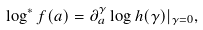<formula> <loc_0><loc_0><loc_500><loc_500>\log ^ { * } f ( a ) = \partial _ { a } ^ { \gamma } \log h ( \gamma ) | _ { \gamma = 0 } ,</formula> 